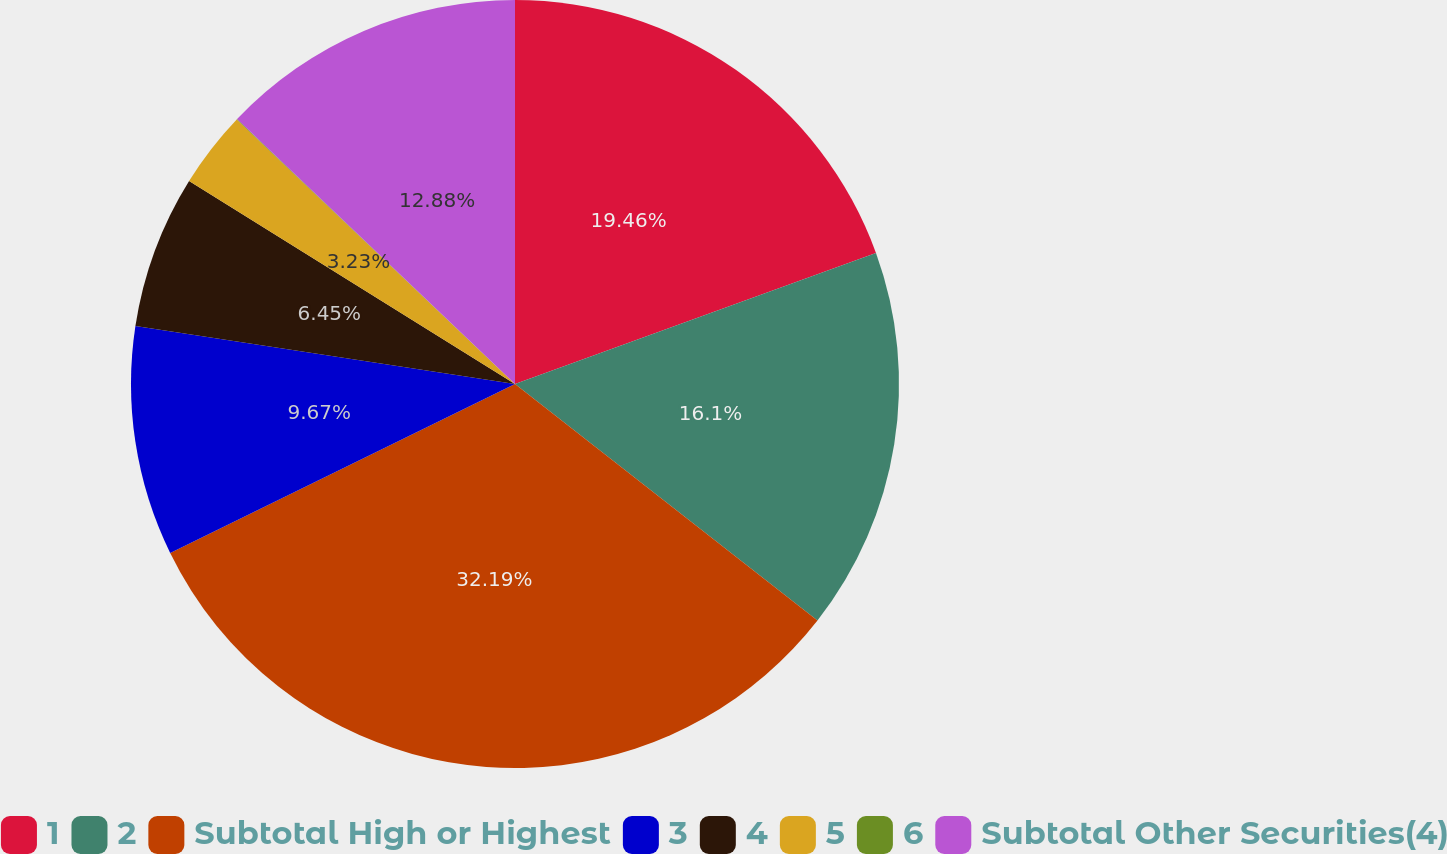<chart> <loc_0><loc_0><loc_500><loc_500><pie_chart><fcel>1<fcel>2<fcel>Subtotal High or Highest<fcel>3<fcel>4<fcel>5<fcel>6<fcel>Subtotal Other Securities(4)<nl><fcel>19.46%<fcel>16.1%<fcel>32.18%<fcel>9.67%<fcel>6.45%<fcel>3.23%<fcel>0.02%<fcel>12.88%<nl></chart> 